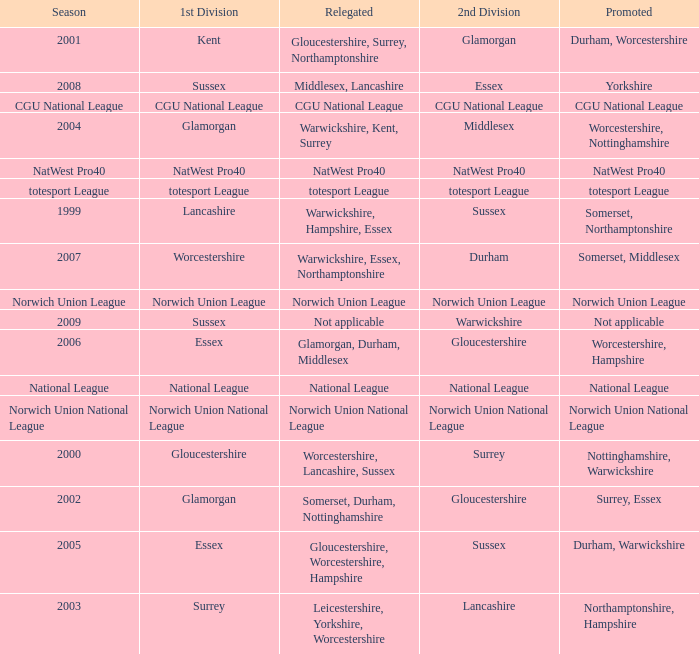What season was Norwich Union League promoted? Norwich Union League. 